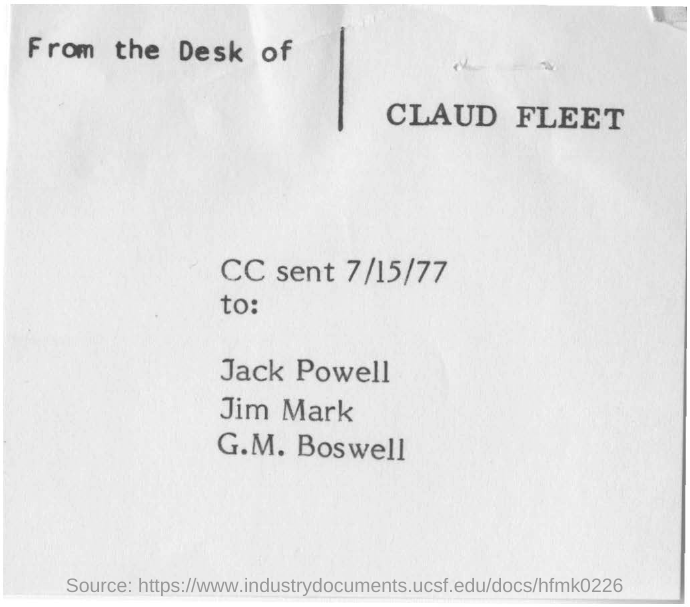What is the date mentioned in the document?
Keep it short and to the point. 7/15/77. From whose desk is this sent?
Make the answer very short. Claud fleet. 